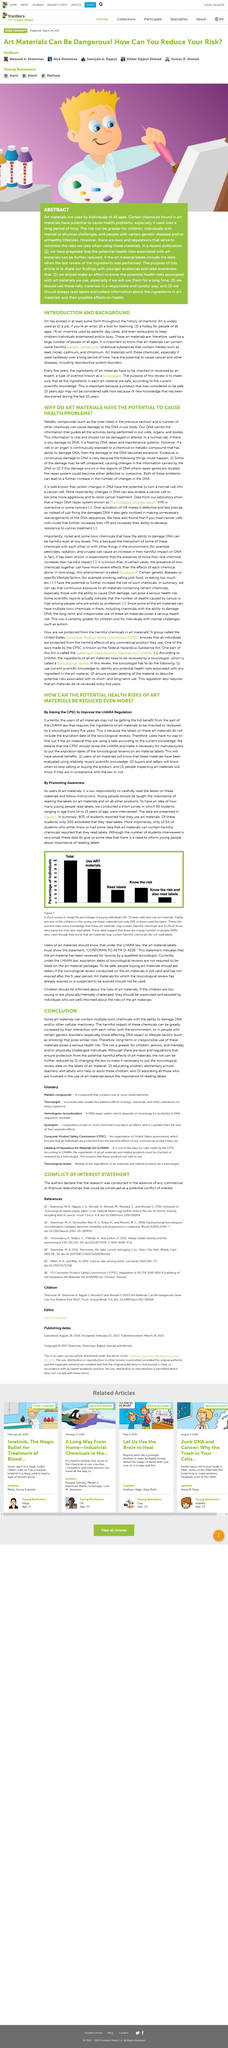Draw attention to some important aspects in this diagram. Art is widely used as a tool for teaching, with the second most common use being in the field of education. This writing is entitled "What is the title of this writing? Introduction and Background..". The presence of harmful metallic compounds, specifically lead, nickel, cadmium, and chromium, in certain art materials can pose significant health risks to those who use them. 